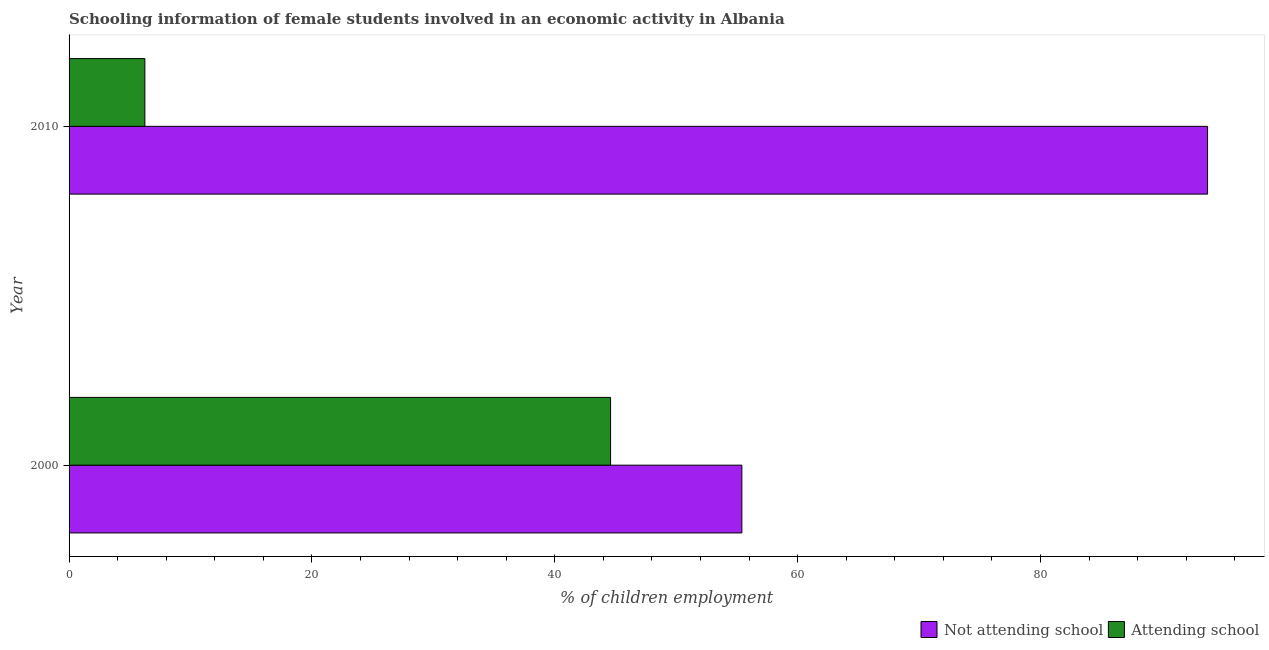How many groups of bars are there?
Make the answer very short. 2. Are the number of bars per tick equal to the number of legend labels?
Keep it short and to the point. Yes. Are the number of bars on each tick of the Y-axis equal?
Keep it short and to the point. Yes. What is the label of the 2nd group of bars from the top?
Your response must be concise. 2000. In how many cases, is the number of bars for a given year not equal to the number of legend labels?
Provide a short and direct response. 0. What is the percentage of employed females who are not attending school in 2000?
Give a very brief answer. 55.41. Across all years, what is the maximum percentage of employed females who are not attending school?
Keep it short and to the point. 93.76. Across all years, what is the minimum percentage of employed females who are not attending school?
Your answer should be compact. 55.41. In which year was the percentage of employed females who are attending school maximum?
Ensure brevity in your answer.  2000. What is the total percentage of employed females who are attending school in the graph?
Offer a terse response. 50.83. What is the difference between the percentage of employed females who are attending school in 2000 and that in 2010?
Provide a succinct answer. 38.35. What is the difference between the percentage of employed females who are attending school in 2000 and the percentage of employed females who are not attending school in 2010?
Ensure brevity in your answer.  -49.17. What is the average percentage of employed females who are not attending school per year?
Provide a succinct answer. 74.58. In the year 2010, what is the difference between the percentage of employed females who are not attending school and percentage of employed females who are attending school?
Your response must be concise. 87.52. What is the ratio of the percentage of employed females who are attending school in 2000 to that in 2010?
Offer a very short reply. 7.14. Is the percentage of employed females who are attending school in 2000 less than that in 2010?
Your response must be concise. No. Is the difference between the percentage of employed females who are not attending school in 2000 and 2010 greater than the difference between the percentage of employed females who are attending school in 2000 and 2010?
Your answer should be very brief. No. What does the 2nd bar from the top in 2000 represents?
Make the answer very short. Not attending school. What does the 2nd bar from the bottom in 2000 represents?
Offer a very short reply. Attending school. Are all the bars in the graph horizontal?
Your response must be concise. Yes. How many years are there in the graph?
Your answer should be very brief. 2. Where does the legend appear in the graph?
Provide a short and direct response. Bottom right. How many legend labels are there?
Offer a very short reply. 2. How are the legend labels stacked?
Offer a very short reply. Horizontal. What is the title of the graph?
Keep it short and to the point. Schooling information of female students involved in an economic activity in Albania. Does "% of GNI" appear as one of the legend labels in the graph?
Ensure brevity in your answer.  No. What is the label or title of the X-axis?
Ensure brevity in your answer.  % of children employment. What is the label or title of the Y-axis?
Make the answer very short. Year. What is the % of children employment in Not attending school in 2000?
Provide a short and direct response. 55.41. What is the % of children employment in Attending school in 2000?
Ensure brevity in your answer.  44.59. What is the % of children employment of Not attending school in 2010?
Your response must be concise. 93.76. What is the % of children employment in Attending school in 2010?
Your answer should be very brief. 6.24. Across all years, what is the maximum % of children employment of Not attending school?
Offer a very short reply. 93.76. Across all years, what is the maximum % of children employment of Attending school?
Your answer should be compact. 44.59. Across all years, what is the minimum % of children employment in Not attending school?
Give a very brief answer. 55.41. Across all years, what is the minimum % of children employment in Attending school?
Ensure brevity in your answer.  6.24. What is the total % of children employment of Not attending school in the graph?
Give a very brief answer. 149.17. What is the total % of children employment of Attending school in the graph?
Make the answer very short. 50.83. What is the difference between the % of children employment of Not attending school in 2000 and that in 2010?
Your answer should be very brief. -38.35. What is the difference between the % of children employment of Attending school in 2000 and that in 2010?
Make the answer very short. 38.35. What is the difference between the % of children employment of Not attending school in 2000 and the % of children employment of Attending school in 2010?
Your answer should be compact. 49.17. What is the average % of children employment in Not attending school per year?
Your answer should be compact. 74.58. What is the average % of children employment of Attending school per year?
Your answer should be compact. 25.42. In the year 2000, what is the difference between the % of children employment in Not attending school and % of children employment in Attending school?
Your response must be concise. 10.81. In the year 2010, what is the difference between the % of children employment in Not attending school and % of children employment in Attending school?
Offer a terse response. 87.52. What is the ratio of the % of children employment of Not attending school in 2000 to that in 2010?
Make the answer very short. 0.59. What is the ratio of the % of children employment of Attending school in 2000 to that in 2010?
Provide a succinct answer. 7.14. What is the difference between the highest and the second highest % of children employment in Not attending school?
Provide a short and direct response. 38.35. What is the difference between the highest and the second highest % of children employment in Attending school?
Keep it short and to the point. 38.35. What is the difference between the highest and the lowest % of children employment in Not attending school?
Provide a succinct answer. 38.35. What is the difference between the highest and the lowest % of children employment in Attending school?
Offer a terse response. 38.35. 